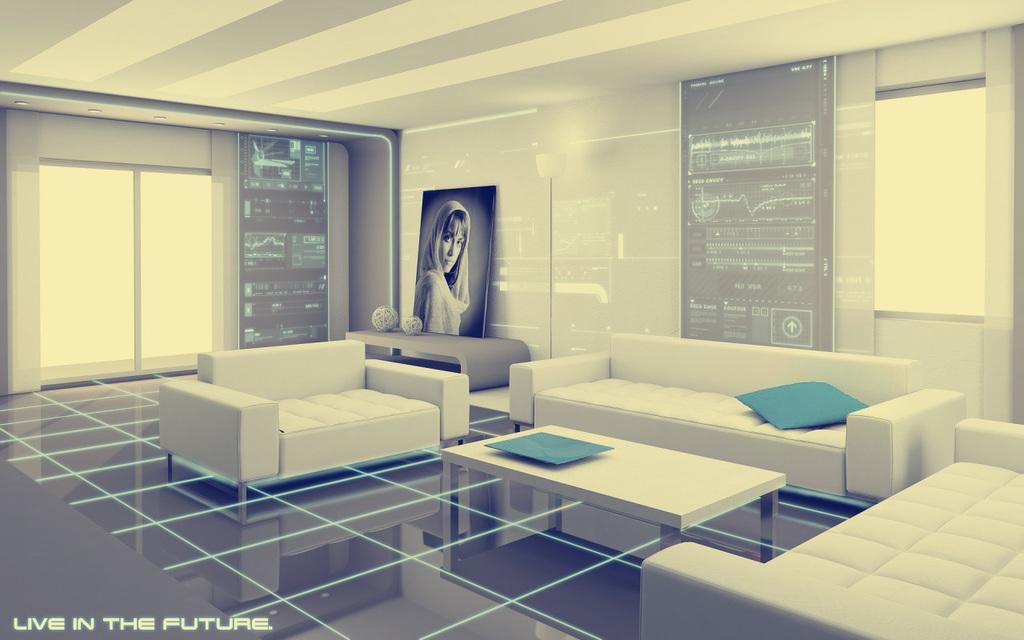In one or two sentences, can you explain what this image depicts? This is an indoor picture. Here we can see sofas and table in white colour. This is a floor. We can see frame of a woman on the table. Here we can see two screens. On the background we can see door. At the top we can see ceiling and lights. 